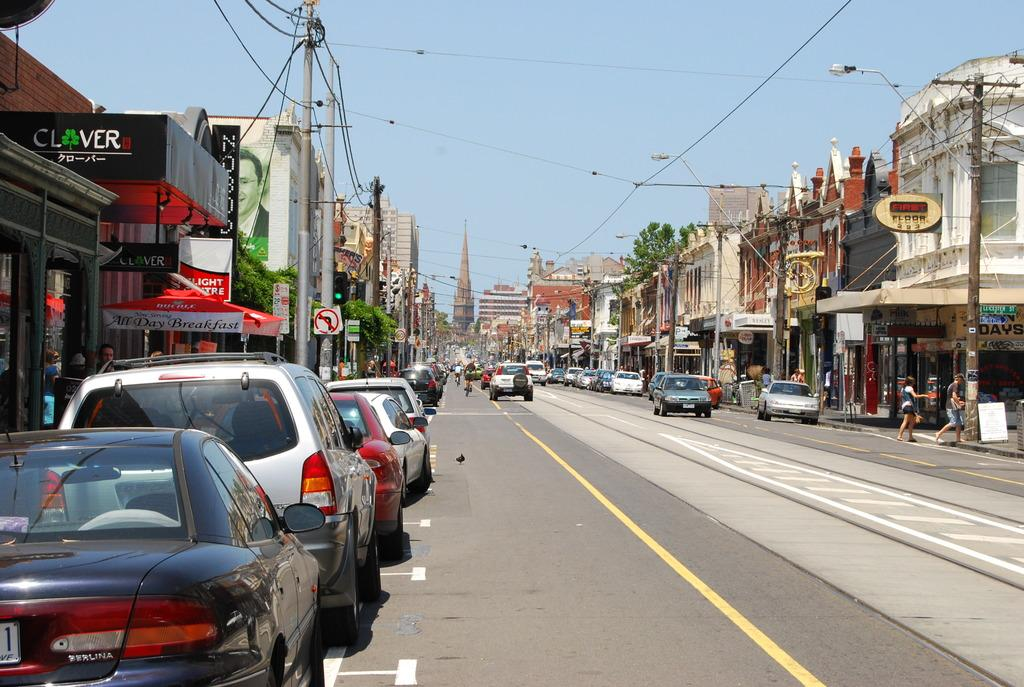Provide a one-sentence caption for the provided image. A street with many parked cars and businesses like one called Clover and another called First Floor. 